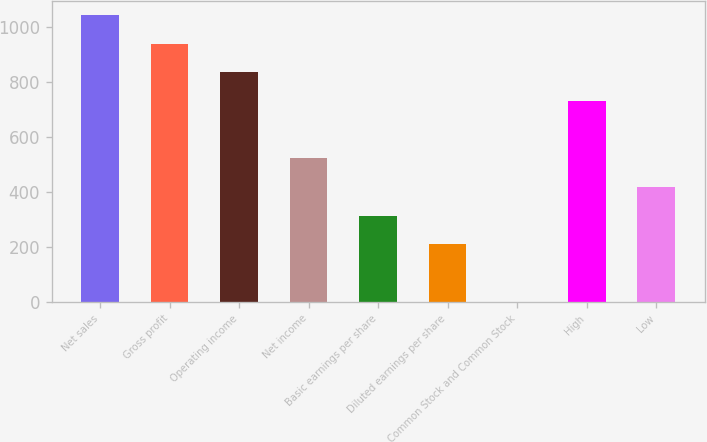Convert chart to OTSL. <chart><loc_0><loc_0><loc_500><loc_500><bar_chart><fcel>Net sales<fcel>Gross profit<fcel>Operating income<fcel>Net income<fcel>Basic earnings per share<fcel>Diluted earnings per share<fcel>Common Stock and Common Stock<fcel>High<fcel>Low<nl><fcel>1043.73<fcel>939.4<fcel>835.07<fcel>522.08<fcel>313.42<fcel>209.09<fcel>0.43<fcel>730.74<fcel>417.75<nl></chart> 